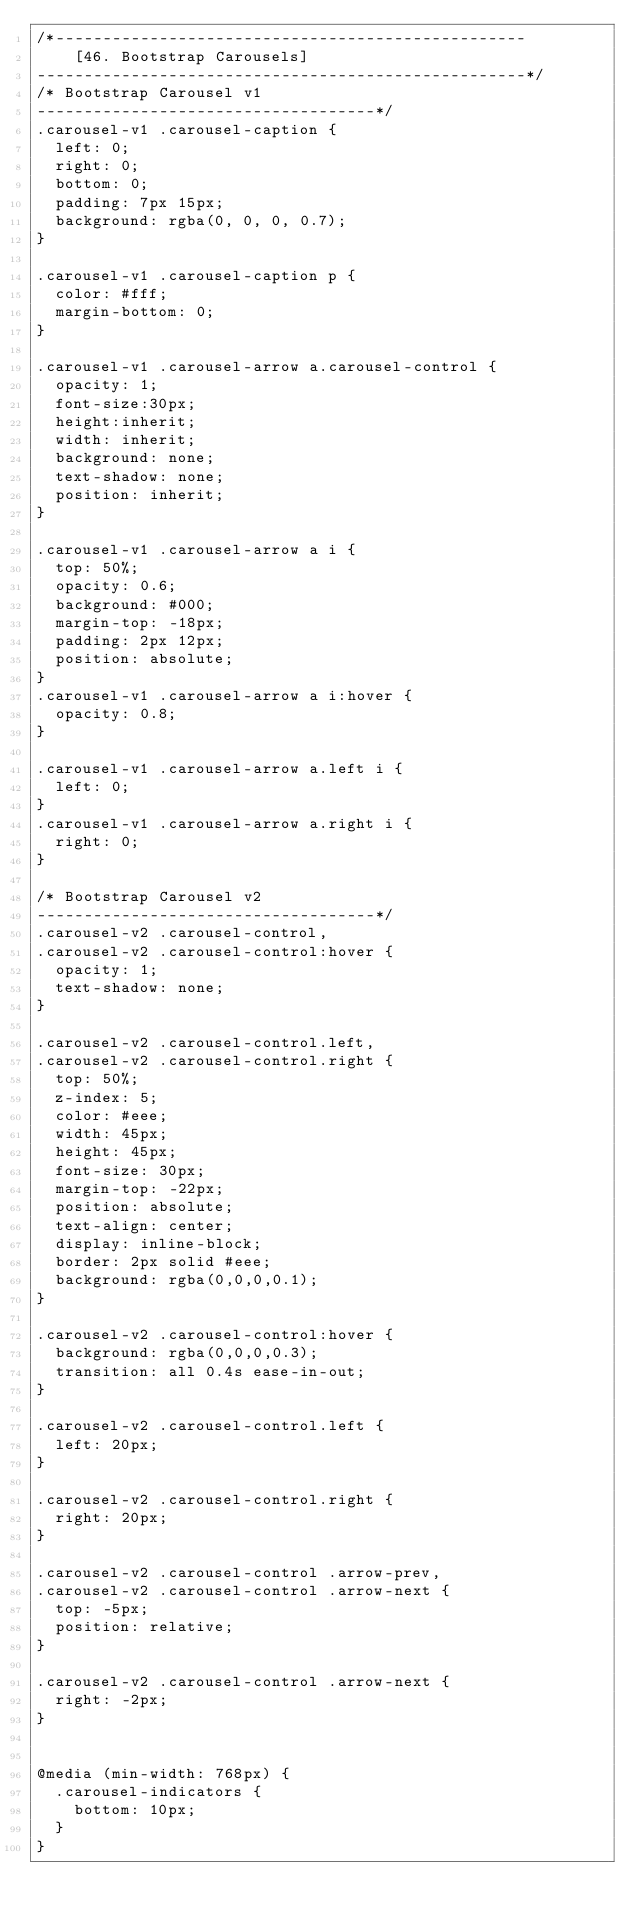<code> <loc_0><loc_0><loc_500><loc_500><_CSS_>/*--------------------------------------------------
	[46. Bootstrap Carousels]
----------------------------------------------------*/
/* Bootstrap Carousel v1
------------------------------------*/
.carousel-v1 .carousel-caption {
  left: 0;
  right: 0;
  bottom: 0;
  padding: 7px 15px;
  background: rgba(0, 0, 0, 0.7);
}

.carousel-v1 .carousel-caption p {
  color: #fff;
  margin-bottom: 0;
}

.carousel-v1 .carousel-arrow a.carousel-control {
  opacity: 1;
  font-size:30px;
  height:inherit;
  width: inherit;
  background: none;
  text-shadow: none;
  position: inherit;
}

.carousel-v1 .carousel-arrow a i {
  top: 50%;
  opacity: 0.6;
  background: #000;
  margin-top: -18px;
  padding: 2px 12px;
  position: absolute;
}
.carousel-v1 .carousel-arrow a i:hover {
  opacity: 0.8;
}

.carousel-v1 .carousel-arrow a.left i {
  left: 0;
}
.carousel-v1 .carousel-arrow a.right i {
  right: 0;
}

/* Bootstrap Carousel v2
------------------------------------*/
.carousel-v2 .carousel-control,
.carousel-v2 .carousel-control:hover {
  opacity: 1;
  text-shadow: none;
}

.carousel-v2 .carousel-control.left,
.carousel-v2 .carousel-control.right {
  top: 50%;
  z-index: 5;
  color: #eee;
  width: 45px;
  height: 45px;
  font-size: 30px;
  margin-top: -22px;
  position: absolute;
  text-align: center;
  display: inline-block;
  border: 2px solid #eee;
  background: rgba(0,0,0,0.1);
}

.carousel-v2 .carousel-control:hover {
  background: rgba(0,0,0,0.3);
  transition: all 0.4s ease-in-out;
}

.carousel-v2 .carousel-control.left {
  left: 20px;
}

.carousel-v2 .carousel-control.right {
  right: 20px;
}

.carousel-v2 .carousel-control .arrow-prev,
.carousel-v2 .carousel-control .arrow-next {
  top: -5px;
  position: relative;
}

.carousel-v2 .carousel-control .arrow-next {
  right: -2px;
}


@media (min-width: 768px) {
  .carousel-indicators {
    bottom: 10px;
  }
}
</code> 